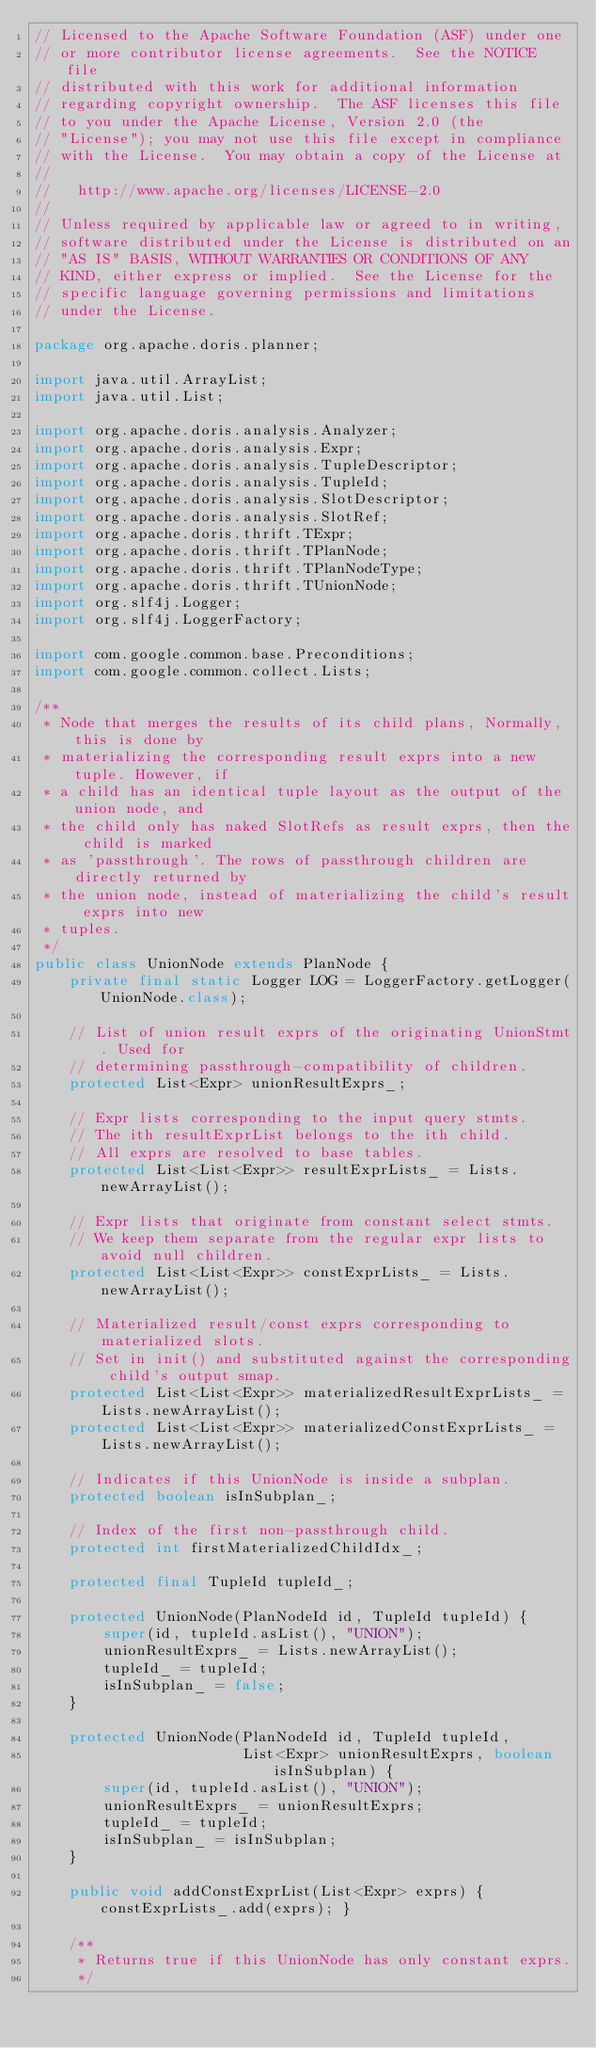Convert code to text. <code><loc_0><loc_0><loc_500><loc_500><_Java_>// Licensed to the Apache Software Foundation (ASF) under one
// or more contributor license agreements.  See the NOTICE file
// distributed with this work for additional information
// regarding copyright ownership.  The ASF licenses this file
// to you under the Apache License, Version 2.0 (the
// "License"); you may not use this file except in compliance
// with the License.  You may obtain a copy of the License at
//
//   http://www.apache.org/licenses/LICENSE-2.0
//
// Unless required by applicable law or agreed to in writing,
// software distributed under the License is distributed on an
// "AS IS" BASIS, WITHOUT WARRANTIES OR CONDITIONS OF ANY
// KIND, either express or implied.  See the License for the
// specific language governing permissions and limitations
// under the License.

package org.apache.doris.planner;

import java.util.ArrayList;
import java.util.List;

import org.apache.doris.analysis.Analyzer;
import org.apache.doris.analysis.Expr;
import org.apache.doris.analysis.TupleDescriptor;
import org.apache.doris.analysis.TupleId;
import org.apache.doris.analysis.SlotDescriptor;
import org.apache.doris.analysis.SlotRef;
import org.apache.doris.thrift.TExpr;
import org.apache.doris.thrift.TPlanNode;
import org.apache.doris.thrift.TPlanNodeType;
import org.apache.doris.thrift.TUnionNode;
import org.slf4j.Logger;
import org.slf4j.LoggerFactory;

import com.google.common.base.Preconditions;
import com.google.common.collect.Lists;

/**
 * Node that merges the results of its child plans, Normally, this is done by
 * materializing the corresponding result exprs into a new tuple. However, if
 * a child has an identical tuple layout as the output of the union node, and
 * the child only has naked SlotRefs as result exprs, then the child is marked
 * as 'passthrough'. The rows of passthrough children are directly returned by
 * the union node, instead of materializing the child's result exprs into new
 * tuples.
 */
public class UnionNode extends PlanNode {
    private final static Logger LOG = LoggerFactory.getLogger(UnionNode.class);

    // List of union result exprs of the originating UnionStmt. Used for
    // determining passthrough-compatibility of children.
    protected List<Expr> unionResultExprs_;

    // Expr lists corresponding to the input query stmts.
    // The ith resultExprList belongs to the ith child.
    // All exprs are resolved to base tables.
    protected List<List<Expr>> resultExprLists_ = Lists.newArrayList();

    // Expr lists that originate from constant select stmts.
    // We keep them separate from the regular expr lists to avoid null children.
    protected List<List<Expr>> constExprLists_ = Lists.newArrayList();

    // Materialized result/const exprs corresponding to materialized slots.
    // Set in init() and substituted against the corresponding child's output smap.
    protected List<List<Expr>> materializedResultExprLists_ = Lists.newArrayList();
    protected List<List<Expr>> materializedConstExprLists_ = Lists.newArrayList();

    // Indicates if this UnionNode is inside a subplan.
    protected boolean isInSubplan_;

    // Index of the first non-passthrough child.
    protected int firstMaterializedChildIdx_;

    protected final TupleId tupleId_;

    protected UnionNode(PlanNodeId id, TupleId tupleId) {
        super(id, tupleId.asList(), "UNION");
        unionResultExprs_ = Lists.newArrayList();
        tupleId_ = tupleId;
        isInSubplan_ = false;
    }

    protected UnionNode(PlanNodeId id, TupleId tupleId,
                        List<Expr> unionResultExprs, boolean isInSubplan) {
        super(id, tupleId.asList(), "UNION");
        unionResultExprs_ = unionResultExprs;
        tupleId_ = tupleId;
        isInSubplan_ = isInSubplan;
    }

    public void addConstExprList(List<Expr> exprs) { constExprLists_.add(exprs); }

    /**
     * Returns true if this UnionNode has only constant exprs.
     */</code> 